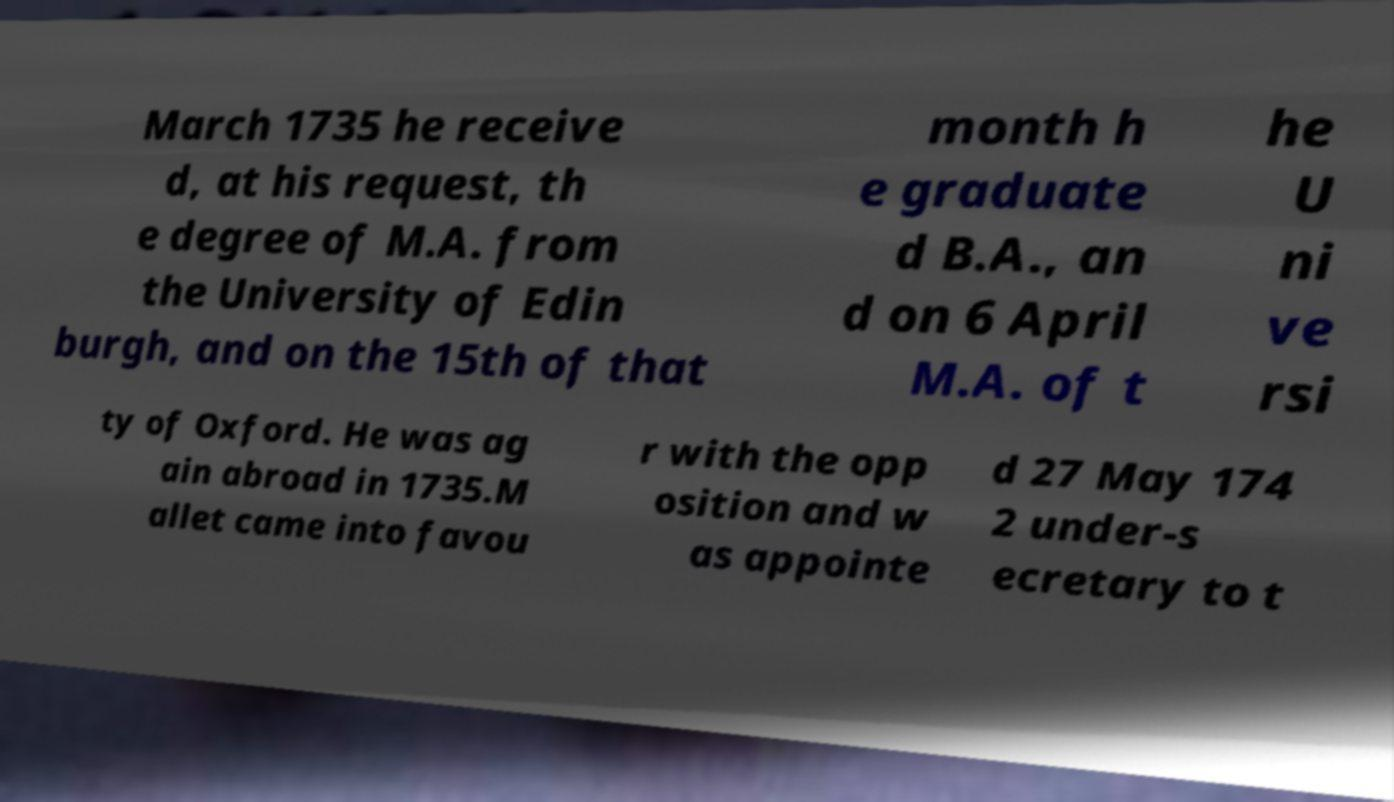Can you accurately transcribe the text from the provided image for me? March 1735 he receive d, at his request, th e degree of M.A. from the University of Edin burgh, and on the 15th of that month h e graduate d B.A., an d on 6 April M.A. of t he U ni ve rsi ty of Oxford. He was ag ain abroad in 1735.M allet came into favou r with the opp osition and w as appointe d 27 May 174 2 under-s ecretary to t 